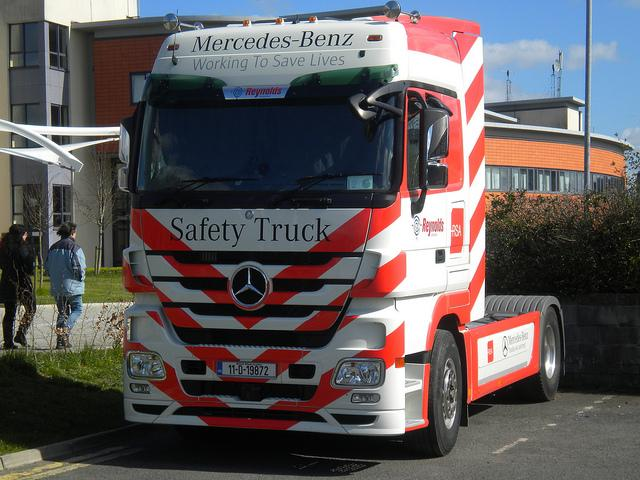Why does it say safety truck? Please explain your reasoning. sell trucks. It's a truck used for safety. 